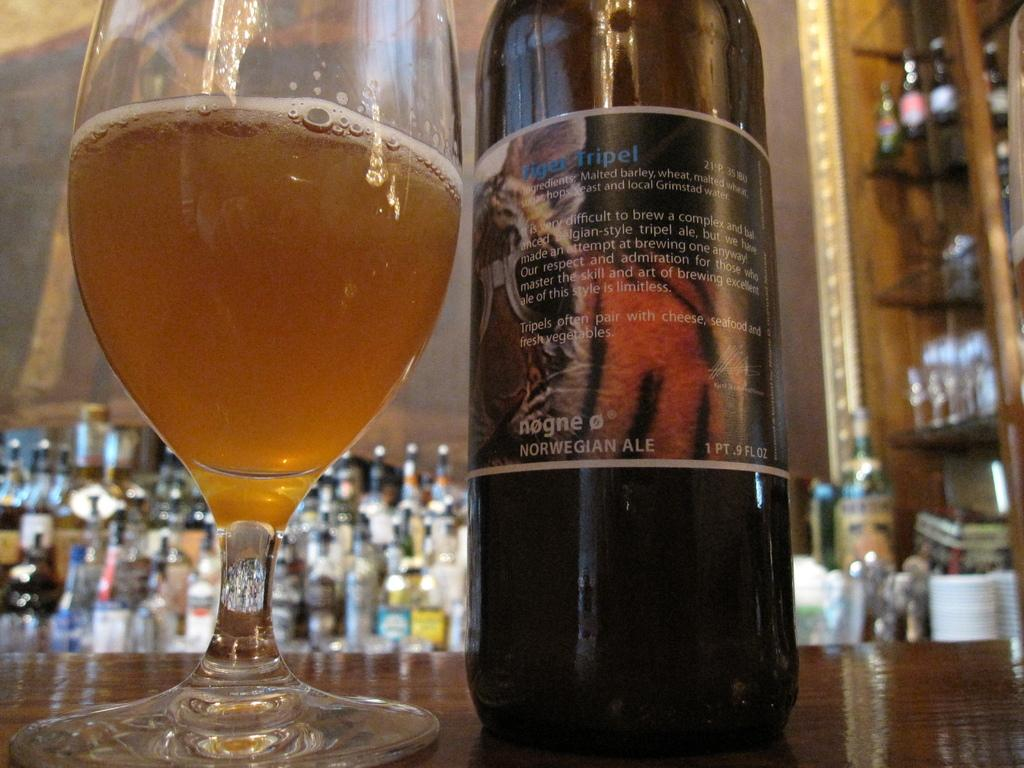What piece of furniture is present in the image? There is a table in the image. What type of container is visible on the table? There is a glass in the image. What other container is present in the image? There is a bottle in the image. How many bottles can be seen in the background of the image? There are multiple bottles in the background of the image. What is located on the right side of the image? There is a cupboard on the right side of the image. Can you tell me which brother is standing next to the stream in the image? There is no brother or stream present in the image. What type of property is shown in the image? The image does not depict a specific property; it shows a table, glass, bottle, multiple bottles, and a cupboard. 